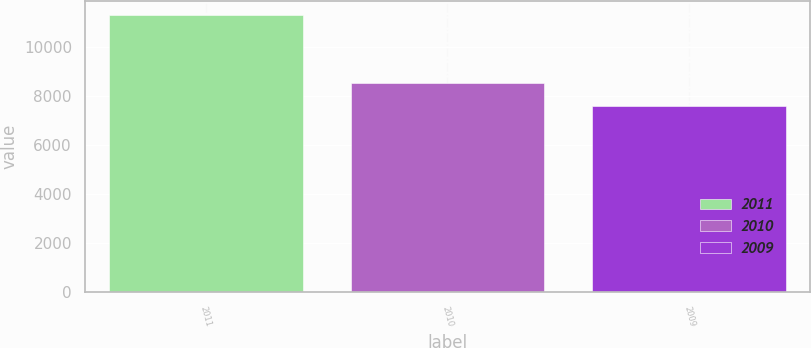<chart> <loc_0><loc_0><loc_500><loc_500><bar_chart><fcel>2011<fcel>2010<fcel>2009<nl><fcel>11287<fcel>8512<fcel>7595<nl></chart> 